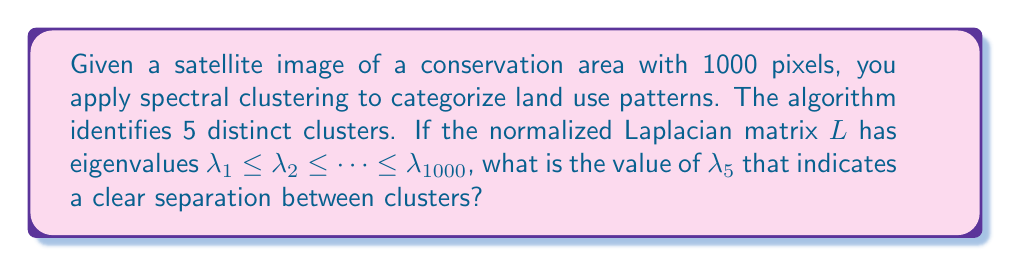What is the answer to this math problem? 1. In spectral clustering, we use the eigenvalues of the normalized Laplacian matrix to determine the number of clusters.

2. The eigenvalues are sorted in ascending order: $\lambda_1 \leq \lambda_2 \leq \cdots \leq \lambda_{1000}$.

3. The number of clusters is determined by the number of eigenvalues close to zero.

4. In this case, we have 5 distinct clusters, so we expect the first 5 eigenvalues to be close to zero.

5. The eigengap heuristic suggests that the number of clusters $k$ is chosen such that $\lambda_1, \ldots, \lambda_k$ are very small, but $\lambda_{k+1}$ is relatively large.

6. Therefore, we are interested in $\lambda_5$, which should be close to zero, while $\lambda_6$ should be significantly larger.

7. For a clear separation between clusters, a typical threshold for $\lambda_5$ is 0.1.

8. If $\lambda_5 \leq 0.1$, it indicates a clear separation between the 5 clusters of land use patterns in the conservation area.
Answer: $\lambda_5 \leq 0.1$ 